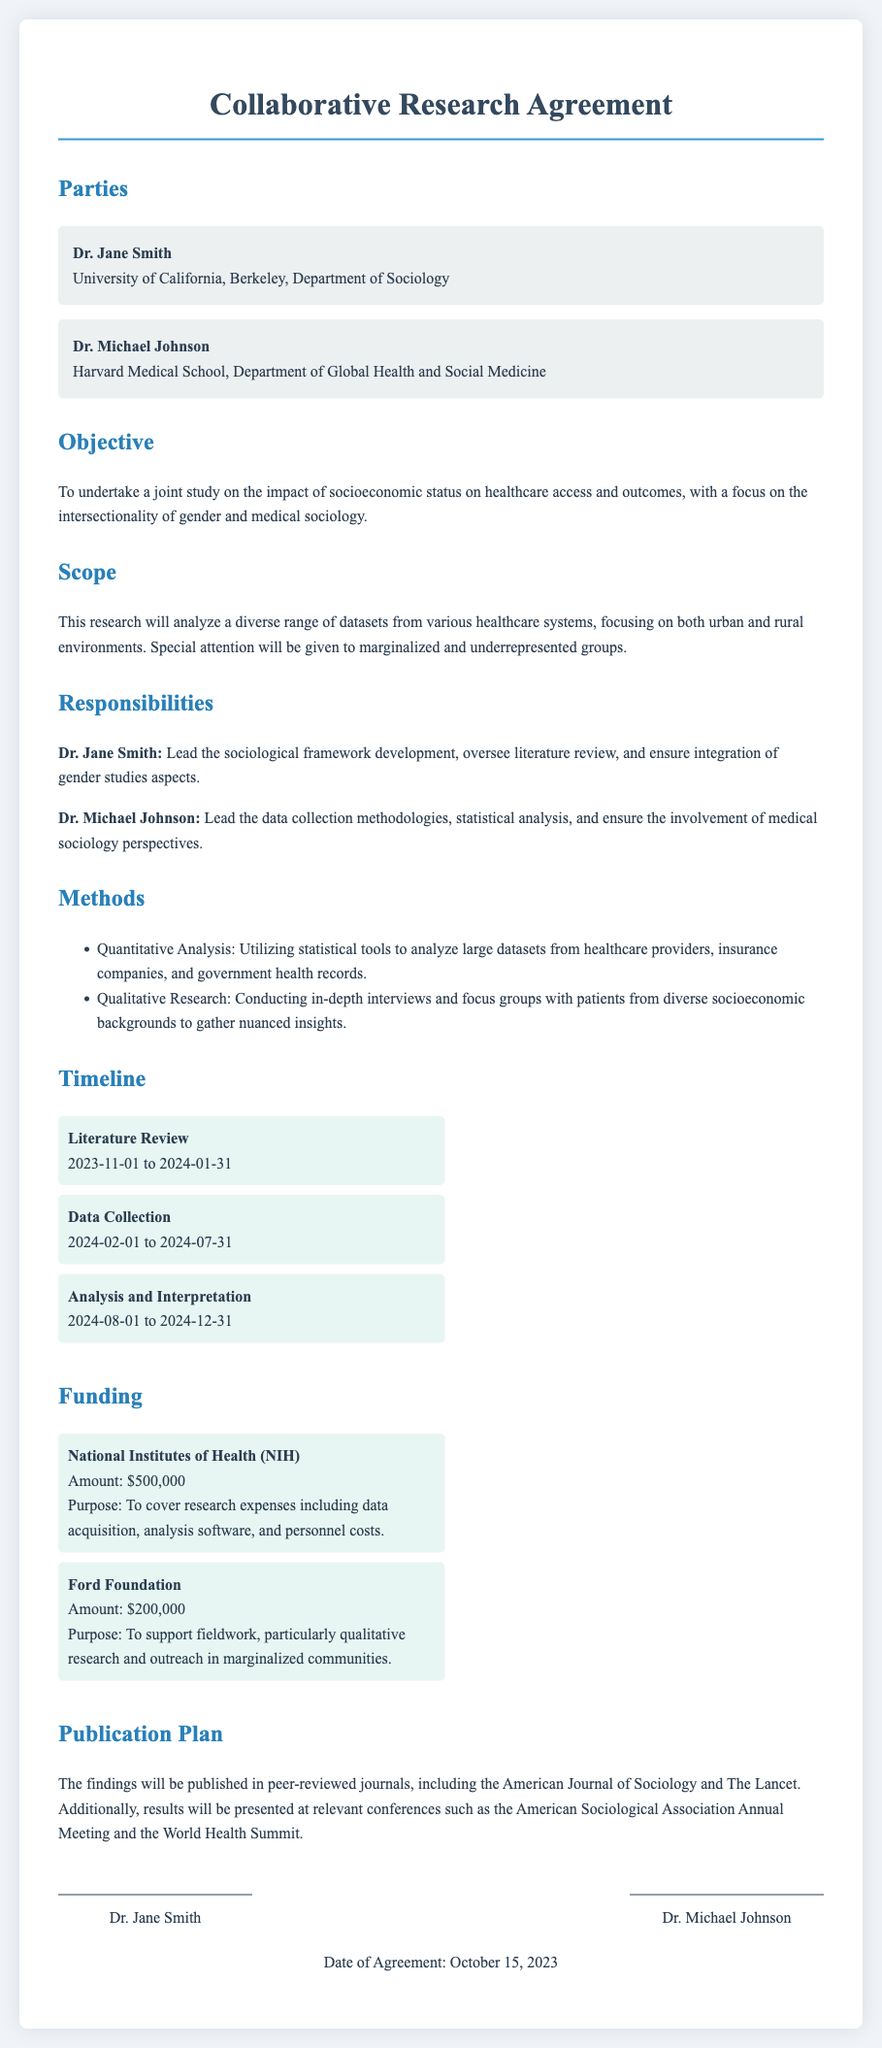What are the names of the parties involved? The document lists two parties: Dr. Jane Smith and Dr. Michael Johnson.
Answer: Dr. Jane Smith, Dr. Michael Johnson What is the main objective of the research? The objective is clearly stated as a joint study on the impact of socioeconomic status on healthcare access and outcomes.
Answer: To undertake a joint study on the impact of socioeconomic status on healthcare access and outcomes What is the total amount of funding from the National Institutes of Health? The document specifies the funding amount from NIH as $500,000.
Answer: $500,000 What is the timeline phase for data collection? The data collection phase is specified to occur from February 1, 2024, to July 31, 2024.
Answer: February 1, 2024, to July 31, 2024 Who is responsible for leading the sociological framework development? The document indicates that Dr. Jane Smith leads the sociological framework development.
Answer: Dr. Jane Smith What qualitative research method is mentioned in the document? In-depth interviews and focus groups with patients are detailed as qualitative research methods.
Answer: In-depth interviews and focus groups What is the total funding amount listed from both sources mentioned? The total funding is the sum of amounts from NIH and Ford Foundation, which is $500,000 + $200,000.
Answer: $700,000 Which journals are specified for publication? The document mentions the American Journal of Sociology and The Lancet for publishing findings.
Answer: American Journal of Sociology and The Lancet What are the years specified for the literature review phase? The timeline indicates that the literature review phase is from November 1, 2023, to January 31, 2024.
Answer: November 1, 2023, to January 31, 2024 